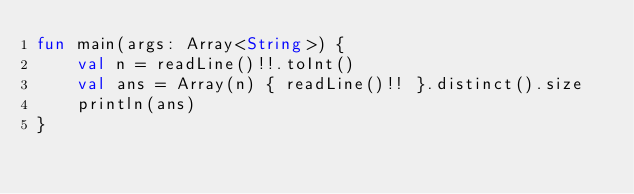Convert code to text. <code><loc_0><loc_0><loc_500><loc_500><_Kotlin_>fun main(args: Array<String>) {
    val n = readLine()!!.toInt()
    val ans = Array(n) { readLine()!! }.distinct().size
    println(ans)
}
</code> 